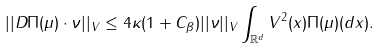Convert formula to latex. <formula><loc_0><loc_0><loc_500><loc_500>| | D \Pi ( \mu ) \cdot \nu | | _ { V } \leq 4 \kappa ( 1 + C _ { \beta } ) | | \nu | | _ { V } \int _ { \mathbb { R } ^ { d } } V ^ { 2 } ( x ) \Pi ( \mu ) ( d x ) .</formula> 